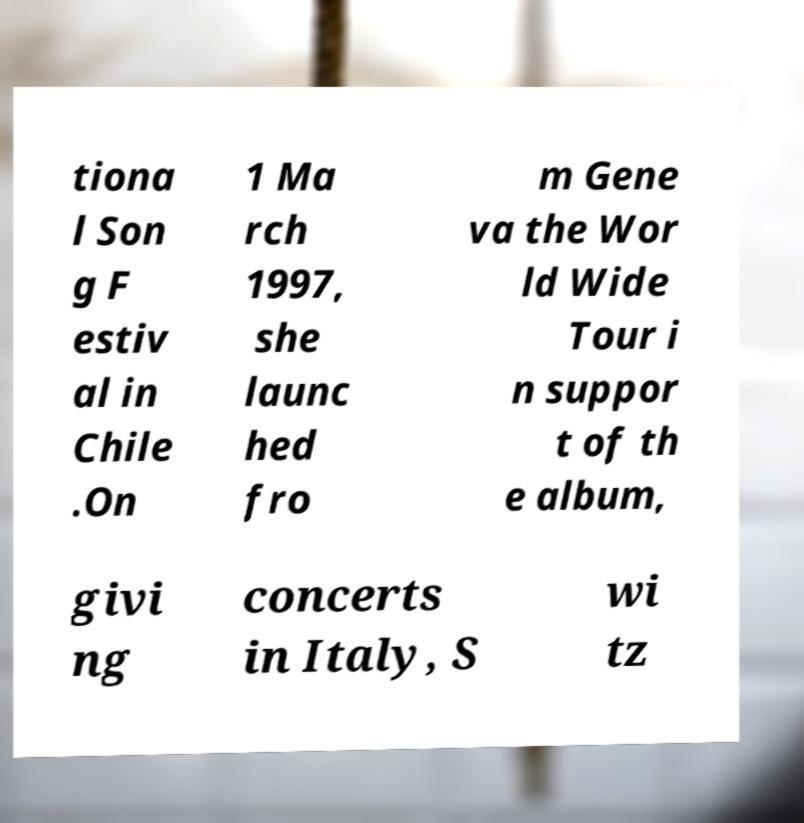Can you accurately transcribe the text from the provided image for me? tiona l Son g F estiv al in Chile .On 1 Ma rch 1997, she launc hed fro m Gene va the Wor ld Wide Tour i n suppor t of th e album, givi ng concerts in Italy, S wi tz 